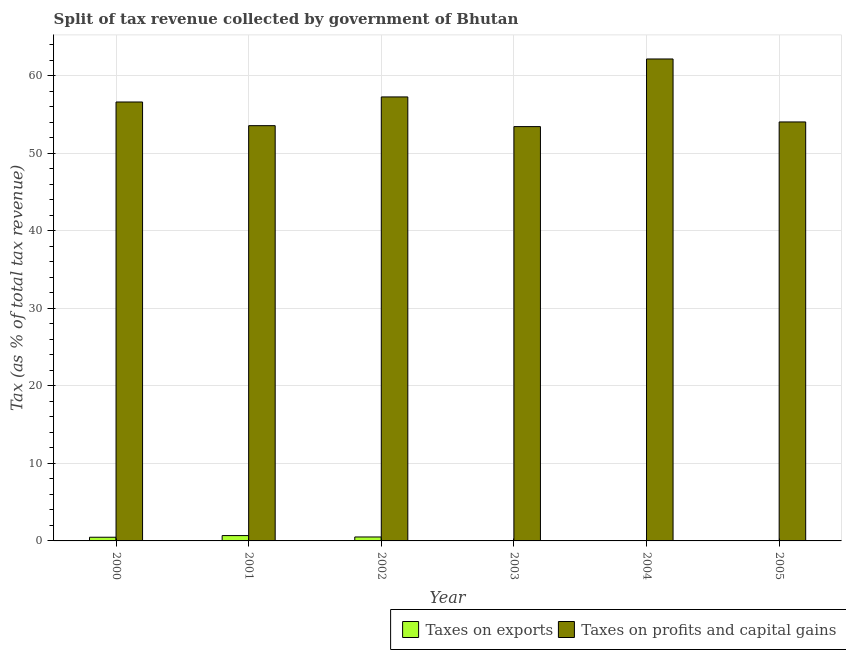How many groups of bars are there?
Your answer should be very brief. 6. How many bars are there on the 3rd tick from the right?
Your answer should be very brief. 2. What is the percentage of revenue obtained from taxes on exports in 2002?
Provide a succinct answer. 0.51. Across all years, what is the maximum percentage of revenue obtained from taxes on exports?
Give a very brief answer. 0.69. Across all years, what is the minimum percentage of revenue obtained from taxes on profits and capital gains?
Your answer should be very brief. 53.45. In which year was the percentage of revenue obtained from taxes on profits and capital gains maximum?
Keep it short and to the point. 2004. In which year was the percentage of revenue obtained from taxes on exports minimum?
Provide a short and direct response. 2004. What is the total percentage of revenue obtained from taxes on exports in the graph?
Make the answer very short. 1.75. What is the difference between the percentage of revenue obtained from taxes on profits and capital gains in 2001 and that in 2005?
Offer a terse response. -0.48. What is the difference between the percentage of revenue obtained from taxes on profits and capital gains in 2005 and the percentage of revenue obtained from taxes on exports in 2002?
Keep it short and to the point. -3.23. What is the average percentage of revenue obtained from taxes on exports per year?
Offer a terse response. 0.29. In the year 2003, what is the difference between the percentage of revenue obtained from taxes on exports and percentage of revenue obtained from taxes on profits and capital gains?
Make the answer very short. 0. What is the ratio of the percentage of revenue obtained from taxes on exports in 2000 to that in 2002?
Offer a terse response. 0.93. Is the difference between the percentage of revenue obtained from taxes on profits and capital gains in 2001 and 2002 greater than the difference between the percentage of revenue obtained from taxes on exports in 2001 and 2002?
Keep it short and to the point. No. What is the difference between the highest and the second highest percentage of revenue obtained from taxes on profits and capital gains?
Provide a short and direct response. 4.9. What is the difference between the highest and the lowest percentage of revenue obtained from taxes on exports?
Offer a very short reply. 0.67. Is the sum of the percentage of revenue obtained from taxes on exports in 2001 and 2002 greater than the maximum percentage of revenue obtained from taxes on profits and capital gains across all years?
Your answer should be compact. Yes. What does the 2nd bar from the left in 2000 represents?
Provide a short and direct response. Taxes on profits and capital gains. What does the 1st bar from the right in 2004 represents?
Your answer should be compact. Taxes on profits and capital gains. How many years are there in the graph?
Your answer should be very brief. 6. What is the difference between two consecutive major ticks on the Y-axis?
Make the answer very short. 10. Are the values on the major ticks of Y-axis written in scientific E-notation?
Ensure brevity in your answer.  No. How many legend labels are there?
Provide a succinct answer. 2. What is the title of the graph?
Your response must be concise. Split of tax revenue collected by government of Bhutan. Does "Female labor force" appear as one of the legend labels in the graph?
Give a very brief answer. No. What is the label or title of the X-axis?
Your response must be concise. Year. What is the label or title of the Y-axis?
Offer a terse response. Tax (as % of total tax revenue). What is the Tax (as % of total tax revenue) of Taxes on exports in 2000?
Your answer should be very brief. 0.48. What is the Tax (as % of total tax revenue) of Taxes on profits and capital gains in 2000?
Provide a succinct answer. 56.62. What is the Tax (as % of total tax revenue) in Taxes on exports in 2001?
Your answer should be very brief. 0.69. What is the Tax (as % of total tax revenue) in Taxes on profits and capital gains in 2001?
Keep it short and to the point. 53.57. What is the Tax (as % of total tax revenue) in Taxes on exports in 2002?
Give a very brief answer. 0.51. What is the Tax (as % of total tax revenue) of Taxes on profits and capital gains in 2002?
Keep it short and to the point. 57.28. What is the Tax (as % of total tax revenue) in Taxes on exports in 2003?
Your response must be concise. 0.03. What is the Tax (as % of total tax revenue) in Taxes on profits and capital gains in 2003?
Ensure brevity in your answer.  53.45. What is the Tax (as % of total tax revenue) of Taxes on exports in 2004?
Provide a succinct answer. 0.02. What is the Tax (as % of total tax revenue) of Taxes on profits and capital gains in 2004?
Ensure brevity in your answer.  62.17. What is the Tax (as % of total tax revenue) of Taxes on exports in 2005?
Offer a very short reply. 0.03. What is the Tax (as % of total tax revenue) in Taxes on profits and capital gains in 2005?
Make the answer very short. 54.05. Across all years, what is the maximum Tax (as % of total tax revenue) in Taxes on exports?
Keep it short and to the point. 0.69. Across all years, what is the maximum Tax (as % of total tax revenue) in Taxes on profits and capital gains?
Offer a very short reply. 62.17. Across all years, what is the minimum Tax (as % of total tax revenue) of Taxes on exports?
Keep it short and to the point. 0.02. Across all years, what is the minimum Tax (as % of total tax revenue) in Taxes on profits and capital gains?
Ensure brevity in your answer.  53.45. What is the total Tax (as % of total tax revenue) in Taxes on exports in the graph?
Offer a very short reply. 1.75. What is the total Tax (as % of total tax revenue) in Taxes on profits and capital gains in the graph?
Provide a succinct answer. 337.14. What is the difference between the Tax (as % of total tax revenue) of Taxes on exports in 2000 and that in 2001?
Make the answer very short. -0.21. What is the difference between the Tax (as % of total tax revenue) of Taxes on profits and capital gains in 2000 and that in 2001?
Your answer should be compact. 3.05. What is the difference between the Tax (as % of total tax revenue) of Taxes on exports in 2000 and that in 2002?
Your answer should be compact. -0.03. What is the difference between the Tax (as % of total tax revenue) of Taxes on profits and capital gains in 2000 and that in 2002?
Provide a succinct answer. -0.65. What is the difference between the Tax (as % of total tax revenue) of Taxes on exports in 2000 and that in 2003?
Provide a short and direct response. 0.45. What is the difference between the Tax (as % of total tax revenue) of Taxes on profits and capital gains in 2000 and that in 2003?
Ensure brevity in your answer.  3.18. What is the difference between the Tax (as % of total tax revenue) in Taxes on exports in 2000 and that in 2004?
Ensure brevity in your answer.  0.46. What is the difference between the Tax (as % of total tax revenue) of Taxes on profits and capital gains in 2000 and that in 2004?
Your answer should be very brief. -5.55. What is the difference between the Tax (as % of total tax revenue) of Taxes on exports in 2000 and that in 2005?
Make the answer very short. 0.45. What is the difference between the Tax (as % of total tax revenue) of Taxes on profits and capital gains in 2000 and that in 2005?
Offer a very short reply. 2.58. What is the difference between the Tax (as % of total tax revenue) of Taxes on exports in 2001 and that in 2002?
Keep it short and to the point. 0.18. What is the difference between the Tax (as % of total tax revenue) in Taxes on profits and capital gains in 2001 and that in 2002?
Your response must be concise. -3.71. What is the difference between the Tax (as % of total tax revenue) in Taxes on exports in 2001 and that in 2003?
Keep it short and to the point. 0.66. What is the difference between the Tax (as % of total tax revenue) in Taxes on profits and capital gains in 2001 and that in 2003?
Your answer should be very brief. 0.12. What is the difference between the Tax (as % of total tax revenue) in Taxes on exports in 2001 and that in 2004?
Give a very brief answer. 0.67. What is the difference between the Tax (as % of total tax revenue) of Taxes on profits and capital gains in 2001 and that in 2004?
Your response must be concise. -8.6. What is the difference between the Tax (as % of total tax revenue) in Taxes on exports in 2001 and that in 2005?
Offer a very short reply. 0.66. What is the difference between the Tax (as % of total tax revenue) in Taxes on profits and capital gains in 2001 and that in 2005?
Keep it short and to the point. -0.48. What is the difference between the Tax (as % of total tax revenue) in Taxes on exports in 2002 and that in 2003?
Offer a terse response. 0.48. What is the difference between the Tax (as % of total tax revenue) in Taxes on profits and capital gains in 2002 and that in 2003?
Offer a terse response. 3.83. What is the difference between the Tax (as % of total tax revenue) of Taxes on exports in 2002 and that in 2004?
Provide a short and direct response. 0.49. What is the difference between the Tax (as % of total tax revenue) of Taxes on profits and capital gains in 2002 and that in 2004?
Give a very brief answer. -4.9. What is the difference between the Tax (as % of total tax revenue) of Taxes on exports in 2002 and that in 2005?
Your response must be concise. 0.48. What is the difference between the Tax (as % of total tax revenue) of Taxes on profits and capital gains in 2002 and that in 2005?
Give a very brief answer. 3.23. What is the difference between the Tax (as % of total tax revenue) of Taxes on exports in 2003 and that in 2004?
Ensure brevity in your answer.  0.01. What is the difference between the Tax (as % of total tax revenue) in Taxes on profits and capital gains in 2003 and that in 2004?
Give a very brief answer. -8.72. What is the difference between the Tax (as % of total tax revenue) in Taxes on exports in 2003 and that in 2005?
Offer a very short reply. -0. What is the difference between the Tax (as % of total tax revenue) of Taxes on profits and capital gains in 2003 and that in 2005?
Provide a short and direct response. -0.6. What is the difference between the Tax (as % of total tax revenue) in Taxes on exports in 2004 and that in 2005?
Ensure brevity in your answer.  -0.01. What is the difference between the Tax (as % of total tax revenue) of Taxes on profits and capital gains in 2004 and that in 2005?
Your response must be concise. 8.12. What is the difference between the Tax (as % of total tax revenue) of Taxes on exports in 2000 and the Tax (as % of total tax revenue) of Taxes on profits and capital gains in 2001?
Your response must be concise. -53.09. What is the difference between the Tax (as % of total tax revenue) of Taxes on exports in 2000 and the Tax (as % of total tax revenue) of Taxes on profits and capital gains in 2002?
Give a very brief answer. -56.8. What is the difference between the Tax (as % of total tax revenue) of Taxes on exports in 2000 and the Tax (as % of total tax revenue) of Taxes on profits and capital gains in 2003?
Your answer should be compact. -52.97. What is the difference between the Tax (as % of total tax revenue) of Taxes on exports in 2000 and the Tax (as % of total tax revenue) of Taxes on profits and capital gains in 2004?
Provide a short and direct response. -61.7. What is the difference between the Tax (as % of total tax revenue) of Taxes on exports in 2000 and the Tax (as % of total tax revenue) of Taxes on profits and capital gains in 2005?
Provide a short and direct response. -53.57. What is the difference between the Tax (as % of total tax revenue) of Taxes on exports in 2001 and the Tax (as % of total tax revenue) of Taxes on profits and capital gains in 2002?
Offer a very short reply. -56.59. What is the difference between the Tax (as % of total tax revenue) in Taxes on exports in 2001 and the Tax (as % of total tax revenue) in Taxes on profits and capital gains in 2003?
Keep it short and to the point. -52.76. What is the difference between the Tax (as % of total tax revenue) of Taxes on exports in 2001 and the Tax (as % of total tax revenue) of Taxes on profits and capital gains in 2004?
Your answer should be very brief. -61.48. What is the difference between the Tax (as % of total tax revenue) in Taxes on exports in 2001 and the Tax (as % of total tax revenue) in Taxes on profits and capital gains in 2005?
Keep it short and to the point. -53.36. What is the difference between the Tax (as % of total tax revenue) in Taxes on exports in 2002 and the Tax (as % of total tax revenue) in Taxes on profits and capital gains in 2003?
Make the answer very short. -52.94. What is the difference between the Tax (as % of total tax revenue) in Taxes on exports in 2002 and the Tax (as % of total tax revenue) in Taxes on profits and capital gains in 2004?
Offer a very short reply. -61.66. What is the difference between the Tax (as % of total tax revenue) in Taxes on exports in 2002 and the Tax (as % of total tax revenue) in Taxes on profits and capital gains in 2005?
Provide a short and direct response. -53.54. What is the difference between the Tax (as % of total tax revenue) of Taxes on exports in 2003 and the Tax (as % of total tax revenue) of Taxes on profits and capital gains in 2004?
Offer a very short reply. -62.14. What is the difference between the Tax (as % of total tax revenue) in Taxes on exports in 2003 and the Tax (as % of total tax revenue) in Taxes on profits and capital gains in 2005?
Offer a terse response. -54.02. What is the difference between the Tax (as % of total tax revenue) of Taxes on exports in 2004 and the Tax (as % of total tax revenue) of Taxes on profits and capital gains in 2005?
Offer a very short reply. -54.03. What is the average Tax (as % of total tax revenue) of Taxes on exports per year?
Offer a terse response. 0.29. What is the average Tax (as % of total tax revenue) of Taxes on profits and capital gains per year?
Ensure brevity in your answer.  56.19. In the year 2000, what is the difference between the Tax (as % of total tax revenue) in Taxes on exports and Tax (as % of total tax revenue) in Taxes on profits and capital gains?
Keep it short and to the point. -56.15. In the year 2001, what is the difference between the Tax (as % of total tax revenue) of Taxes on exports and Tax (as % of total tax revenue) of Taxes on profits and capital gains?
Provide a short and direct response. -52.88. In the year 2002, what is the difference between the Tax (as % of total tax revenue) in Taxes on exports and Tax (as % of total tax revenue) in Taxes on profits and capital gains?
Provide a short and direct response. -56.77. In the year 2003, what is the difference between the Tax (as % of total tax revenue) of Taxes on exports and Tax (as % of total tax revenue) of Taxes on profits and capital gains?
Offer a very short reply. -53.42. In the year 2004, what is the difference between the Tax (as % of total tax revenue) of Taxes on exports and Tax (as % of total tax revenue) of Taxes on profits and capital gains?
Provide a short and direct response. -62.15. In the year 2005, what is the difference between the Tax (as % of total tax revenue) in Taxes on exports and Tax (as % of total tax revenue) in Taxes on profits and capital gains?
Offer a terse response. -54.02. What is the ratio of the Tax (as % of total tax revenue) in Taxes on exports in 2000 to that in 2001?
Keep it short and to the point. 0.69. What is the ratio of the Tax (as % of total tax revenue) of Taxes on profits and capital gains in 2000 to that in 2001?
Keep it short and to the point. 1.06. What is the ratio of the Tax (as % of total tax revenue) of Taxes on exports in 2000 to that in 2002?
Your response must be concise. 0.93. What is the ratio of the Tax (as % of total tax revenue) of Taxes on profits and capital gains in 2000 to that in 2002?
Offer a terse response. 0.99. What is the ratio of the Tax (as % of total tax revenue) in Taxes on exports in 2000 to that in 2003?
Give a very brief answer. 16.91. What is the ratio of the Tax (as % of total tax revenue) of Taxes on profits and capital gains in 2000 to that in 2003?
Provide a short and direct response. 1.06. What is the ratio of the Tax (as % of total tax revenue) in Taxes on exports in 2000 to that in 2004?
Offer a very short reply. 23.69. What is the ratio of the Tax (as % of total tax revenue) in Taxes on profits and capital gains in 2000 to that in 2004?
Provide a short and direct response. 0.91. What is the ratio of the Tax (as % of total tax revenue) of Taxes on exports in 2000 to that in 2005?
Your response must be concise. 16.47. What is the ratio of the Tax (as % of total tax revenue) of Taxes on profits and capital gains in 2000 to that in 2005?
Keep it short and to the point. 1.05. What is the ratio of the Tax (as % of total tax revenue) of Taxes on exports in 2001 to that in 2002?
Your answer should be compact. 1.35. What is the ratio of the Tax (as % of total tax revenue) of Taxes on profits and capital gains in 2001 to that in 2002?
Your response must be concise. 0.94. What is the ratio of the Tax (as % of total tax revenue) of Taxes on exports in 2001 to that in 2003?
Provide a succinct answer. 24.49. What is the ratio of the Tax (as % of total tax revenue) of Taxes on profits and capital gains in 2001 to that in 2003?
Provide a short and direct response. 1. What is the ratio of the Tax (as % of total tax revenue) of Taxes on exports in 2001 to that in 2004?
Your answer should be compact. 34.31. What is the ratio of the Tax (as % of total tax revenue) in Taxes on profits and capital gains in 2001 to that in 2004?
Provide a short and direct response. 0.86. What is the ratio of the Tax (as % of total tax revenue) of Taxes on exports in 2001 to that in 2005?
Provide a succinct answer. 23.86. What is the ratio of the Tax (as % of total tax revenue) in Taxes on exports in 2002 to that in 2003?
Your response must be concise. 18.11. What is the ratio of the Tax (as % of total tax revenue) of Taxes on profits and capital gains in 2002 to that in 2003?
Make the answer very short. 1.07. What is the ratio of the Tax (as % of total tax revenue) of Taxes on exports in 2002 to that in 2004?
Provide a short and direct response. 25.37. What is the ratio of the Tax (as % of total tax revenue) of Taxes on profits and capital gains in 2002 to that in 2004?
Ensure brevity in your answer.  0.92. What is the ratio of the Tax (as % of total tax revenue) in Taxes on exports in 2002 to that in 2005?
Provide a short and direct response. 17.64. What is the ratio of the Tax (as % of total tax revenue) in Taxes on profits and capital gains in 2002 to that in 2005?
Provide a succinct answer. 1.06. What is the ratio of the Tax (as % of total tax revenue) of Taxes on exports in 2003 to that in 2004?
Make the answer very short. 1.4. What is the ratio of the Tax (as % of total tax revenue) in Taxes on profits and capital gains in 2003 to that in 2004?
Your answer should be compact. 0.86. What is the ratio of the Tax (as % of total tax revenue) in Taxes on exports in 2003 to that in 2005?
Offer a very short reply. 0.97. What is the ratio of the Tax (as % of total tax revenue) in Taxes on profits and capital gains in 2003 to that in 2005?
Your answer should be very brief. 0.99. What is the ratio of the Tax (as % of total tax revenue) in Taxes on exports in 2004 to that in 2005?
Provide a succinct answer. 0.7. What is the ratio of the Tax (as % of total tax revenue) of Taxes on profits and capital gains in 2004 to that in 2005?
Provide a succinct answer. 1.15. What is the difference between the highest and the second highest Tax (as % of total tax revenue) in Taxes on exports?
Offer a terse response. 0.18. What is the difference between the highest and the second highest Tax (as % of total tax revenue) in Taxes on profits and capital gains?
Provide a succinct answer. 4.9. What is the difference between the highest and the lowest Tax (as % of total tax revenue) in Taxes on exports?
Offer a terse response. 0.67. What is the difference between the highest and the lowest Tax (as % of total tax revenue) in Taxes on profits and capital gains?
Keep it short and to the point. 8.72. 